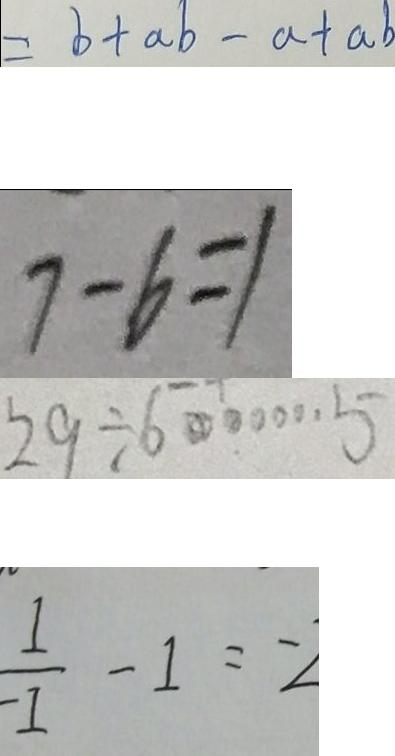<formula> <loc_0><loc_0><loc_500><loc_500>= b + a b - a + a b 
 7 - 6 = 1 
 2 9 \div 6 \cdots 5 
 \frac { 1 } { - 1 } - 1 = - 2</formula> 